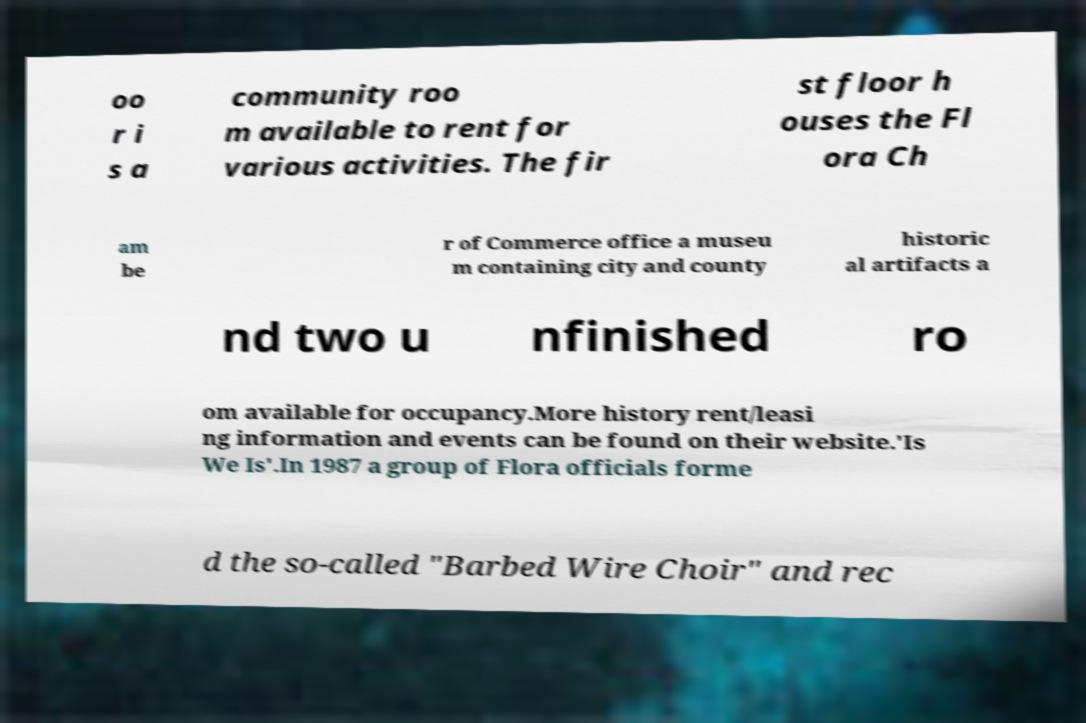Can you read and provide the text displayed in the image?This photo seems to have some interesting text. Can you extract and type it out for me? oo r i s a community roo m available to rent for various activities. The fir st floor h ouses the Fl ora Ch am be r of Commerce office a museu m containing city and county historic al artifacts a nd two u nfinished ro om available for occupancy.More history rent/leasi ng information and events can be found on their website.'Is We Is'.In 1987 a group of Flora officials forme d the so-called "Barbed Wire Choir" and rec 